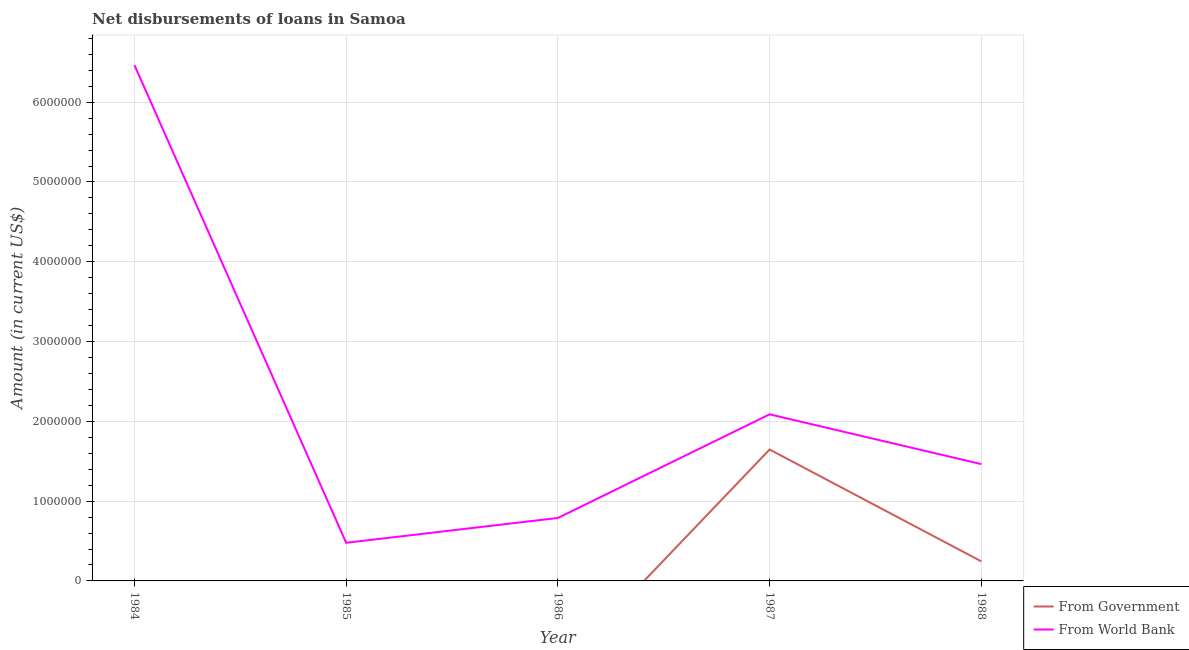Does the line corresponding to net disbursements of loan from world bank intersect with the line corresponding to net disbursements of loan from government?
Your answer should be very brief. No. What is the net disbursements of loan from world bank in 1986?
Make the answer very short. 7.89e+05. Across all years, what is the maximum net disbursements of loan from government?
Your answer should be compact. 1.65e+06. Across all years, what is the minimum net disbursements of loan from world bank?
Ensure brevity in your answer.  4.78e+05. In which year was the net disbursements of loan from government maximum?
Make the answer very short. 1987. What is the total net disbursements of loan from world bank in the graph?
Provide a short and direct response. 1.13e+07. What is the difference between the net disbursements of loan from world bank in 1984 and that in 1986?
Provide a succinct answer. 5.68e+06. What is the difference between the net disbursements of loan from world bank in 1986 and the net disbursements of loan from government in 1988?
Provide a short and direct response. 5.44e+05. What is the average net disbursements of loan from government per year?
Provide a short and direct response. 3.78e+05. In the year 1988, what is the difference between the net disbursements of loan from world bank and net disbursements of loan from government?
Provide a succinct answer. 1.22e+06. In how many years, is the net disbursements of loan from world bank greater than 600000 US$?
Your answer should be very brief. 4. What is the ratio of the net disbursements of loan from world bank in 1984 to that in 1987?
Ensure brevity in your answer.  3.1. What is the difference between the highest and the second highest net disbursements of loan from world bank?
Make the answer very short. 4.38e+06. What is the difference between the highest and the lowest net disbursements of loan from government?
Provide a short and direct response. 1.65e+06. In how many years, is the net disbursements of loan from world bank greater than the average net disbursements of loan from world bank taken over all years?
Give a very brief answer. 1. Is the sum of the net disbursements of loan from world bank in 1985 and 1987 greater than the maximum net disbursements of loan from government across all years?
Offer a terse response. Yes. Does the net disbursements of loan from government monotonically increase over the years?
Give a very brief answer. No. Is the net disbursements of loan from world bank strictly greater than the net disbursements of loan from government over the years?
Ensure brevity in your answer.  Yes. Is the net disbursements of loan from government strictly less than the net disbursements of loan from world bank over the years?
Provide a succinct answer. Yes. How many years are there in the graph?
Ensure brevity in your answer.  5. How are the legend labels stacked?
Provide a succinct answer. Vertical. What is the title of the graph?
Your answer should be very brief. Net disbursements of loans in Samoa. Does "By country of asylum" appear as one of the legend labels in the graph?
Your answer should be compact. No. What is the label or title of the X-axis?
Make the answer very short. Year. What is the label or title of the Y-axis?
Offer a terse response. Amount (in current US$). What is the Amount (in current US$) in From World Bank in 1984?
Keep it short and to the point. 6.46e+06. What is the Amount (in current US$) in From Government in 1985?
Provide a succinct answer. 0. What is the Amount (in current US$) in From World Bank in 1985?
Your response must be concise. 4.78e+05. What is the Amount (in current US$) of From World Bank in 1986?
Your response must be concise. 7.89e+05. What is the Amount (in current US$) of From Government in 1987?
Keep it short and to the point. 1.65e+06. What is the Amount (in current US$) in From World Bank in 1987?
Provide a succinct answer. 2.09e+06. What is the Amount (in current US$) in From Government in 1988?
Your answer should be very brief. 2.45e+05. What is the Amount (in current US$) of From World Bank in 1988?
Provide a succinct answer. 1.46e+06. Across all years, what is the maximum Amount (in current US$) in From Government?
Make the answer very short. 1.65e+06. Across all years, what is the maximum Amount (in current US$) in From World Bank?
Your response must be concise. 6.46e+06. Across all years, what is the minimum Amount (in current US$) in From World Bank?
Your answer should be very brief. 4.78e+05. What is the total Amount (in current US$) in From Government in the graph?
Provide a succinct answer. 1.89e+06. What is the total Amount (in current US$) of From World Bank in the graph?
Provide a short and direct response. 1.13e+07. What is the difference between the Amount (in current US$) in From World Bank in 1984 and that in 1985?
Offer a very short reply. 5.99e+06. What is the difference between the Amount (in current US$) of From World Bank in 1984 and that in 1986?
Your answer should be very brief. 5.68e+06. What is the difference between the Amount (in current US$) in From World Bank in 1984 and that in 1987?
Give a very brief answer. 4.38e+06. What is the difference between the Amount (in current US$) in From World Bank in 1985 and that in 1986?
Your answer should be compact. -3.11e+05. What is the difference between the Amount (in current US$) of From World Bank in 1985 and that in 1987?
Make the answer very short. -1.61e+06. What is the difference between the Amount (in current US$) of From World Bank in 1985 and that in 1988?
Your answer should be very brief. -9.86e+05. What is the difference between the Amount (in current US$) of From World Bank in 1986 and that in 1987?
Offer a very short reply. -1.30e+06. What is the difference between the Amount (in current US$) in From World Bank in 1986 and that in 1988?
Your answer should be very brief. -6.75e+05. What is the difference between the Amount (in current US$) in From Government in 1987 and that in 1988?
Your answer should be very brief. 1.40e+06. What is the difference between the Amount (in current US$) in From World Bank in 1987 and that in 1988?
Provide a short and direct response. 6.24e+05. What is the difference between the Amount (in current US$) in From Government in 1987 and the Amount (in current US$) in From World Bank in 1988?
Ensure brevity in your answer.  1.83e+05. What is the average Amount (in current US$) of From Government per year?
Your answer should be very brief. 3.78e+05. What is the average Amount (in current US$) in From World Bank per year?
Provide a short and direct response. 2.26e+06. In the year 1987, what is the difference between the Amount (in current US$) in From Government and Amount (in current US$) in From World Bank?
Offer a very short reply. -4.41e+05. In the year 1988, what is the difference between the Amount (in current US$) in From Government and Amount (in current US$) in From World Bank?
Make the answer very short. -1.22e+06. What is the ratio of the Amount (in current US$) in From World Bank in 1984 to that in 1985?
Your response must be concise. 13.52. What is the ratio of the Amount (in current US$) in From World Bank in 1984 to that in 1986?
Give a very brief answer. 8.19. What is the ratio of the Amount (in current US$) of From World Bank in 1984 to that in 1987?
Make the answer very short. 3.1. What is the ratio of the Amount (in current US$) of From World Bank in 1984 to that in 1988?
Make the answer very short. 4.42. What is the ratio of the Amount (in current US$) in From World Bank in 1985 to that in 1986?
Offer a terse response. 0.61. What is the ratio of the Amount (in current US$) of From World Bank in 1985 to that in 1987?
Make the answer very short. 0.23. What is the ratio of the Amount (in current US$) in From World Bank in 1985 to that in 1988?
Offer a terse response. 0.33. What is the ratio of the Amount (in current US$) in From World Bank in 1986 to that in 1987?
Keep it short and to the point. 0.38. What is the ratio of the Amount (in current US$) of From World Bank in 1986 to that in 1988?
Make the answer very short. 0.54. What is the ratio of the Amount (in current US$) of From Government in 1987 to that in 1988?
Give a very brief answer. 6.72. What is the ratio of the Amount (in current US$) in From World Bank in 1987 to that in 1988?
Offer a terse response. 1.43. What is the difference between the highest and the second highest Amount (in current US$) in From World Bank?
Provide a succinct answer. 4.38e+06. What is the difference between the highest and the lowest Amount (in current US$) of From Government?
Keep it short and to the point. 1.65e+06. What is the difference between the highest and the lowest Amount (in current US$) in From World Bank?
Offer a very short reply. 5.99e+06. 